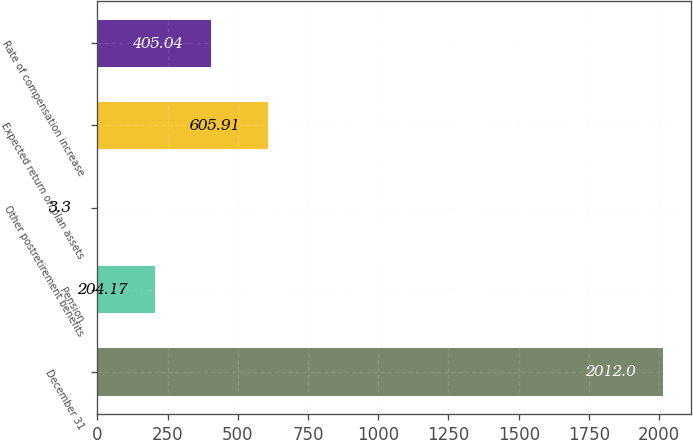<chart> <loc_0><loc_0><loc_500><loc_500><bar_chart><fcel>December 31<fcel>Pension<fcel>Other postretirement benefits<fcel>Expected return on plan assets<fcel>Rate of compensation increase<nl><fcel>2012<fcel>204.17<fcel>3.3<fcel>605.91<fcel>405.04<nl></chart> 